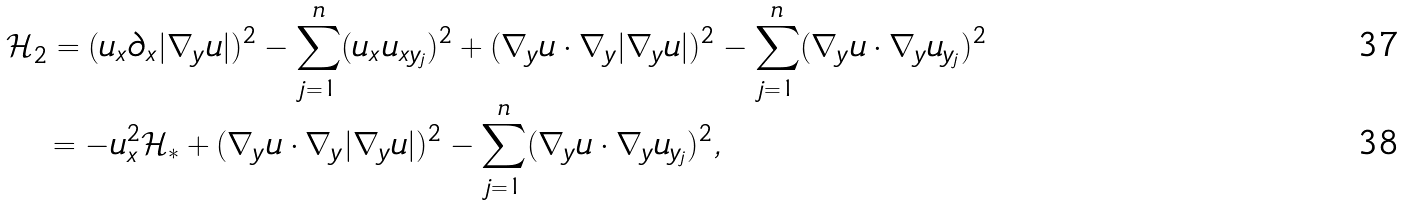Convert formula to latex. <formula><loc_0><loc_0><loc_500><loc_500>& \mathcal { H } _ { 2 } = ( u _ { x } \partial _ { x } | \nabla _ { y } u | ) ^ { 2 } - \sum _ { j = 1 } ^ { n } ( u _ { x } u _ { x y _ { j } } ) ^ { 2 } + ( \nabla _ { y } u \cdot \nabla _ { y } | \nabla _ { y } u | ) ^ { 2 } - \sum _ { j = 1 } ^ { n } ( \nabla _ { y } u \cdot \nabla _ { y } u _ { y _ { j } } ) ^ { 2 } \\ & \quad = - u _ { x } ^ { 2 } \mathcal { H } _ { * } + ( \nabla _ { y } u \cdot \nabla _ { y } | \nabla _ { y } u | ) ^ { 2 } - \sum _ { j = 1 } ^ { n } ( \nabla _ { y } u \cdot \nabla _ { y } u _ { y _ { j } } ) ^ { 2 } ,</formula> 